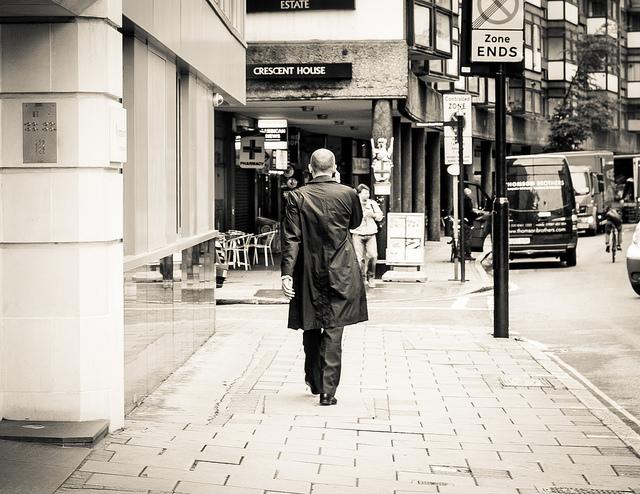Is the man on the sidewalk wearing a raincoat?
Be succinct. Yes. Is the cyclist traveling toward or away from us?
Write a very short answer. Away. How can you tell this is an urban area?
Keep it brief. Buildings. What bank name is shown on the left side?
Short answer required. None. 